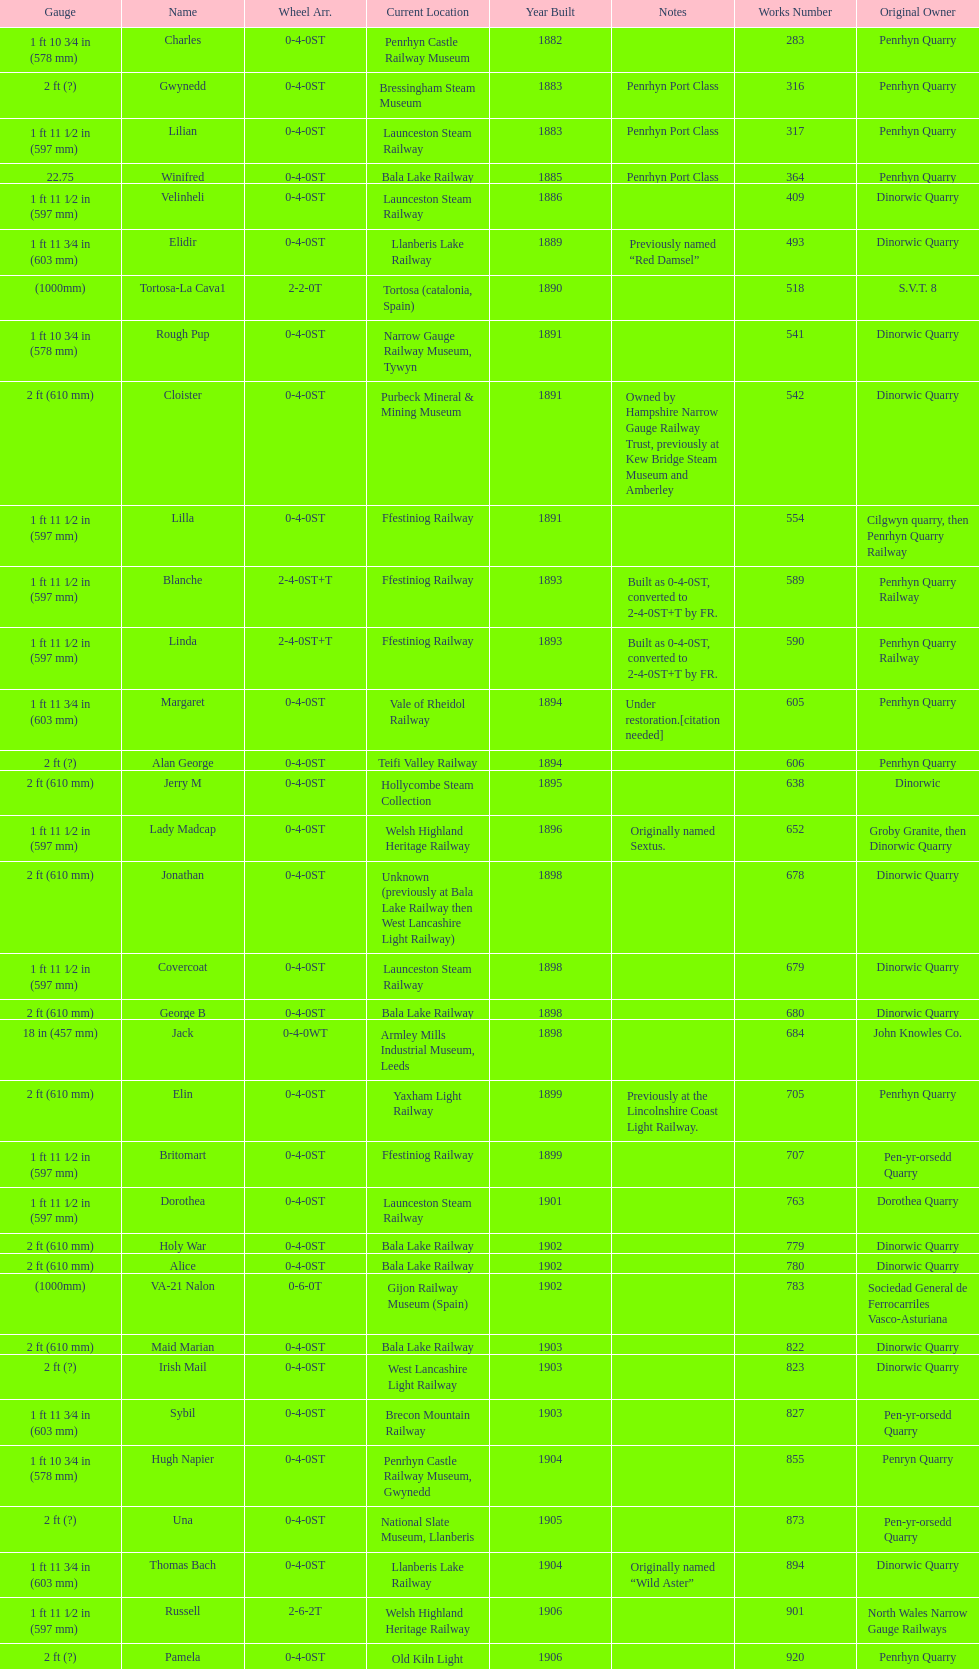Aside from 316, what was the other works number used in 1883? 317. 